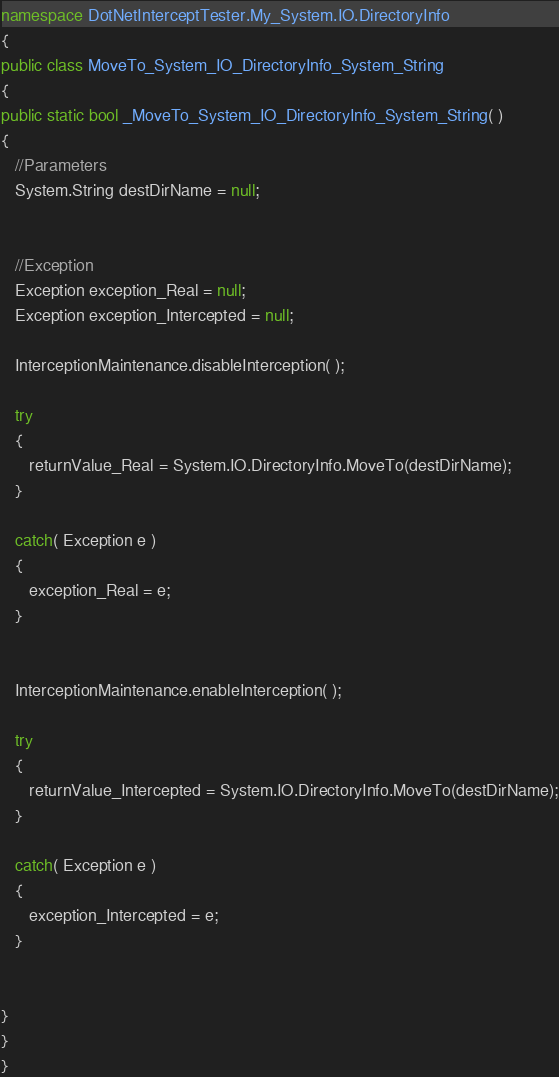Convert code to text. <code><loc_0><loc_0><loc_500><loc_500><_C#_>namespace DotNetInterceptTester.My_System.IO.DirectoryInfo
{
public class MoveTo_System_IO_DirectoryInfo_System_String
{
public static bool _MoveTo_System_IO_DirectoryInfo_System_String( )
{
   //Parameters
   System.String destDirName = null;


   //Exception
   Exception exception_Real = null;
   Exception exception_Intercepted = null;

   InterceptionMaintenance.disableInterception( );

   try
   {
      returnValue_Real = System.IO.DirectoryInfo.MoveTo(destDirName);
   }

   catch( Exception e )
   {
      exception_Real = e;
   }


   InterceptionMaintenance.enableInterception( );

   try
   {
      returnValue_Intercepted = System.IO.DirectoryInfo.MoveTo(destDirName);
   }

   catch( Exception e )
   {
      exception_Intercepted = e;
   }


}
}
}
</code> 